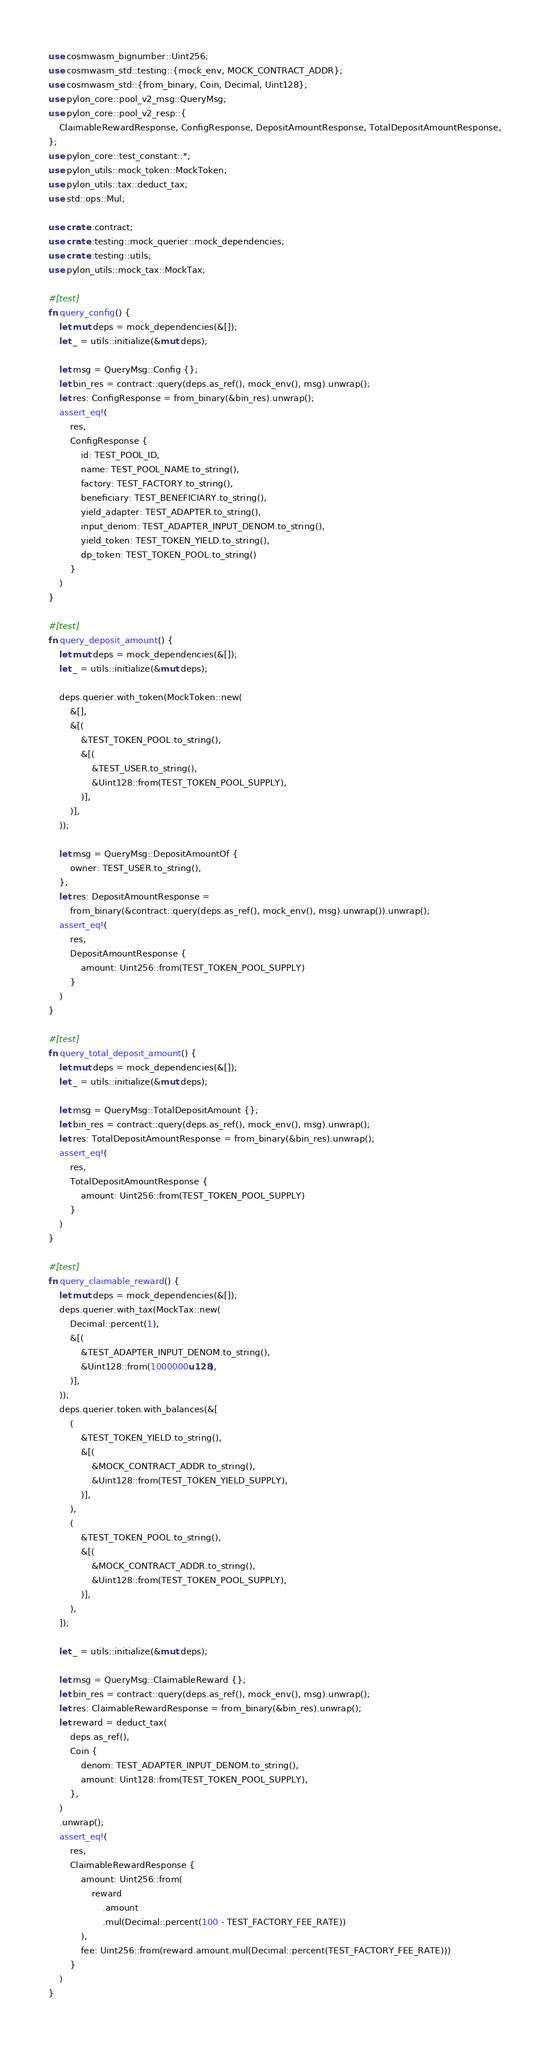Convert code to text. <code><loc_0><loc_0><loc_500><loc_500><_Rust_>use cosmwasm_bignumber::Uint256;
use cosmwasm_std::testing::{mock_env, MOCK_CONTRACT_ADDR};
use cosmwasm_std::{from_binary, Coin, Decimal, Uint128};
use pylon_core::pool_v2_msg::QueryMsg;
use pylon_core::pool_v2_resp::{
    ClaimableRewardResponse, ConfigResponse, DepositAmountResponse, TotalDepositAmountResponse,
};
use pylon_core::test_constant::*;
use pylon_utils::mock_token::MockToken;
use pylon_utils::tax::deduct_tax;
use std::ops::Mul;

use crate::contract;
use crate::testing::mock_querier::mock_dependencies;
use crate::testing::utils;
use pylon_utils::mock_tax::MockTax;

#[test]
fn query_config() {
    let mut deps = mock_dependencies(&[]);
    let _ = utils::initialize(&mut deps);

    let msg = QueryMsg::Config {};
    let bin_res = contract::query(deps.as_ref(), mock_env(), msg).unwrap();
    let res: ConfigResponse = from_binary(&bin_res).unwrap();
    assert_eq!(
        res,
        ConfigResponse {
            id: TEST_POOL_ID,
            name: TEST_POOL_NAME.to_string(),
            factory: TEST_FACTORY.to_string(),
            beneficiary: TEST_BENEFICIARY.to_string(),
            yield_adapter: TEST_ADAPTER.to_string(),
            input_denom: TEST_ADAPTER_INPUT_DENOM.to_string(),
            yield_token: TEST_TOKEN_YIELD.to_string(),
            dp_token: TEST_TOKEN_POOL.to_string()
        }
    )
}

#[test]
fn query_deposit_amount() {
    let mut deps = mock_dependencies(&[]);
    let _ = utils::initialize(&mut deps);

    deps.querier.with_token(MockToken::new(
        &[],
        &[(
            &TEST_TOKEN_POOL.to_string(),
            &[(
                &TEST_USER.to_string(),
                &Uint128::from(TEST_TOKEN_POOL_SUPPLY),
            )],
        )],
    ));

    let msg = QueryMsg::DepositAmountOf {
        owner: TEST_USER.to_string(),
    };
    let res: DepositAmountResponse =
        from_binary(&contract::query(deps.as_ref(), mock_env(), msg).unwrap()).unwrap();
    assert_eq!(
        res,
        DepositAmountResponse {
            amount: Uint256::from(TEST_TOKEN_POOL_SUPPLY)
        }
    )
}

#[test]
fn query_total_deposit_amount() {
    let mut deps = mock_dependencies(&[]);
    let _ = utils::initialize(&mut deps);

    let msg = QueryMsg::TotalDepositAmount {};
    let bin_res = contract::query(deps.as_ref(), mock_env(), msg).unwrap();
    let res: TotalDepositAmountResponse = from_binary(&bin_res).unwrap();
    assert_eq!(
        res,
        TotalDepositAmountResponse {
            amount: Uint256::from(TEST_TOKEN_POOL_SUPPLY)
        }
    )
}

#[test]
fn query_claimable_reward() {
    let mut deps = mock_dependencies(&[]);
    deps.querier.with_tax(MockTax::new(
        Decimal::percent(1),
        &[(
            &TEST_ADAPTER_INPUT_DENOM.to_string(),
            &Uint128::from(1000000u128),
        )],
    ));
    deps.querier.token.with_balances(&[
        (
            &TEST_TOKEN_YIELD.to_string(),
            &[(
                &MOCK_CONTRACT_ADDR.to_string(),
                &Uint128::from(TEST_TOKEN_YIELD_SUPPLY),
            )],
        ),
        (
            &TEST_TOKEN_POOL.to_string(),
            &[(
                &MOCK_CONTRACT_ADDR.to_string(),
                &Uint128::from(TEST_TOKEN_POOL_SUPPLY),
            )],
        ),
    ]);

    let _ = utils::initialize(&mut deps);

    let msg = QueryMsg::ClaimableReward {};
    let bin_res = contract::query(deps.as_ref(), mock_env(), msg).unwrap();
    let res: ClaimableRewardResponse = from_binary(&bin_res).unwrap();
    let reward = deduct_tax(
        deps.as_ref(),
        Coin {
            denom: TEST_ADAPTER_INPUT_DENOM.to_string(),
            amount: Uint128::from(TEST_TOKEN_POOL_SUPPLY),
        },
    )
    .unwrap();
    assert_eq!(
        res,
        ClaimableRewardResponse {
            amount: Uint256::from(
                reward
                    .amount
                    .mul(Decimal::percent(100 - TEST_FACTORY_FEE_RATE))
            ),
            fee: Uint256::from(reward.amount.mul(Decimal::percent(TEST_FACTORY_FEE_RATE)))
        }
    )
}
</code> 